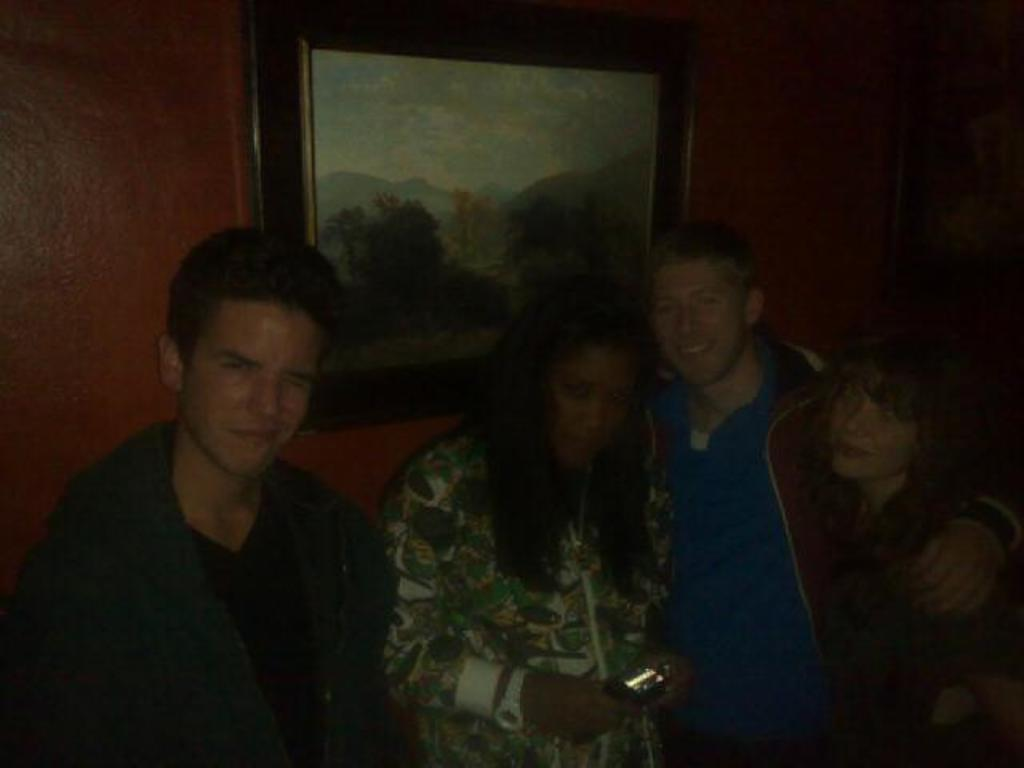How many people are in the image? There are persons in the image, but the exact number is not specified. What are the persons wearing? The persons are wearing clothes. What can be seen on the wall in the image? There is a photo frame on the wall in the image. What type of scent can be smelled coming from the yard in the image? There is no yard present in the image, so it is not possible to determine what scent might be smelled. 